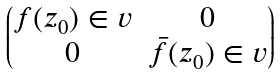Convert formula to latex. <formula><loc_0><loc_0><loc_500><loc_500>\begin{pmatrix} f ( z _ { 0 } ) \in v & 0 \\ 0 & \bar { f } ( z _ { 0 } ) \in v \end{pmatrix}</formula> 